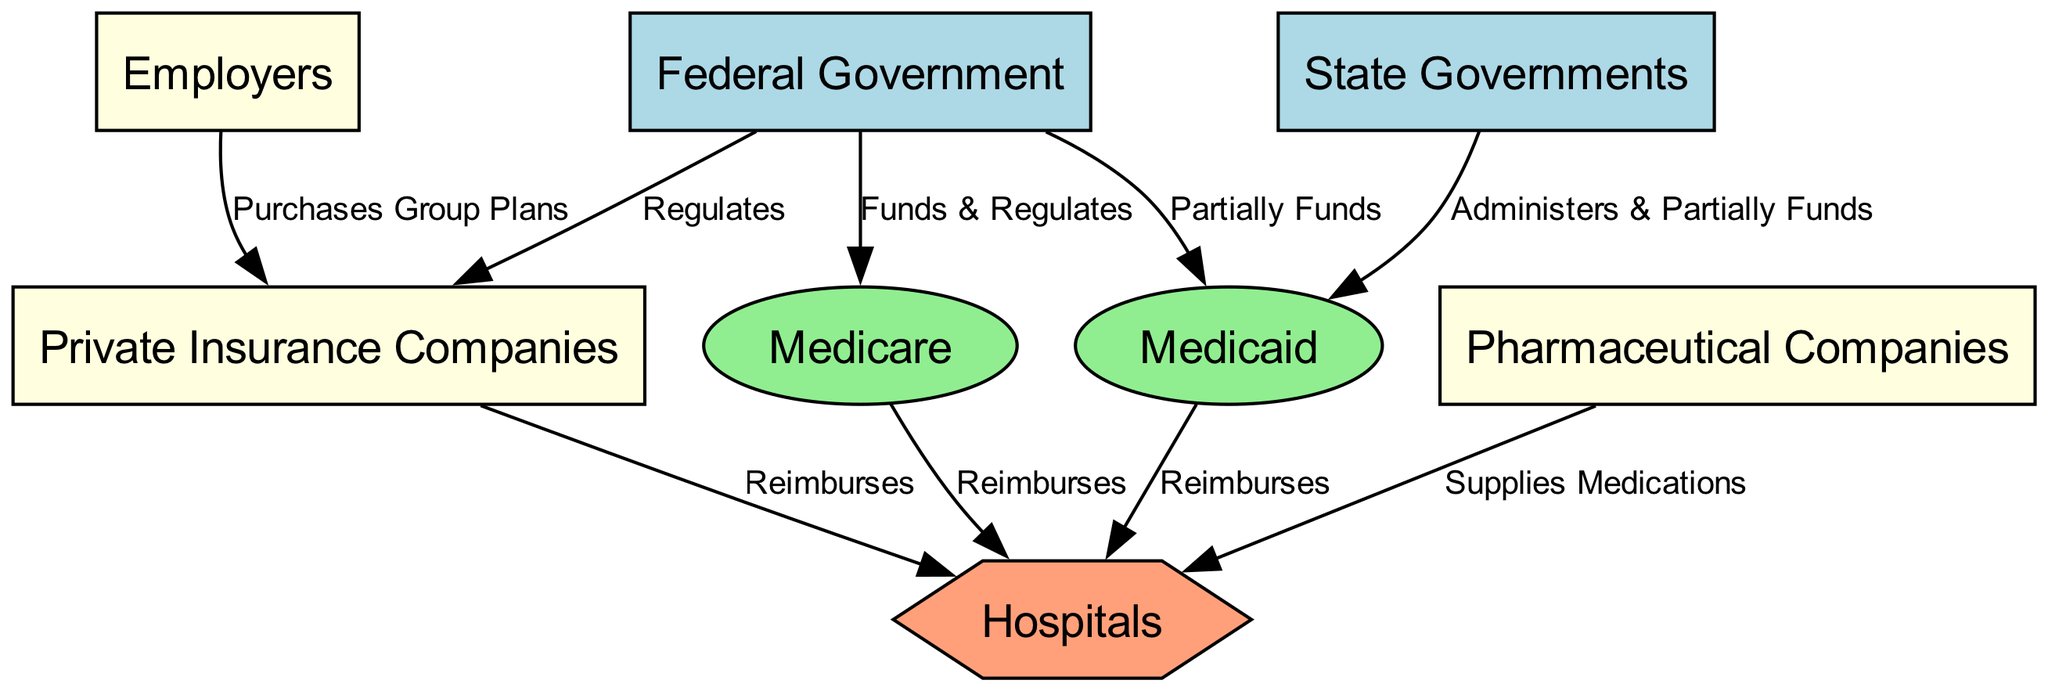What are the two major public sectors represented in the diagram? The diagram includes the Federal Government and State Governments as major public sectors. Therefore, by identifying the nodes labeled 'Federal Government' and 'State Governments', we determine that these are the specific entities in the public sector.
Answer: Federal Government, State Governments How many public health insurance entities are shown in the diagram? The diagram features two public health insurance entities: Medicare and Medicaid. These can be easily identified as the nodes labeled 'Medicare' and 'Medicaid' under the public health insurance category.
Answer: 2 Who regulates the private insurance companies? The Federal Government is responsible for regulating private insurance companies, as indicated by the edge labeled 'Regulates' that connects the Federal Government to Private Insurance Companies in the diagram.
Answer: Federal Government What action do employers take regarding private insurance companies? Employers purchase group plans from private insurance companies, which is shown through the edge labeled 'Purchases Group Plans' connecting Employers to Private Insurance Companies.
Answer: Purchases Group Plans Which sector partially funds Medicaid? State Governments partially fund Medicaid, as indicated by the edge labeled 'Administers & Partially Funds' connecting State Governments to Medicaid. This establishes the financial relationship in funding public health insurance.
Answer: State Governments Between which two types of entities does the Medicare reimbursement flow? The Medicare reimbursement flows between Medicare and Hospitals, as shown by the edge labeled 'Reimburses' connecting these two nodes. This indicates that Medicare provides financial reimbursement to hospitals for healthcare services.
Answer: Medicare, Hospitals What do pharmaceutical companies supply to hospitals? Pharmaceutical Companies supply medications to hospitals, indicated by the edge labeled 'Supplies Medications' connecting these two entities in the diagram. This highlights the role of pharmaceutical companies in the healthcare supply chain.
Answer: Medications What is the main role of the Federal Government regarding Medicare? The Federal Government funds and regulates Medicare, as indicated by the edge labeled 'Funds & Regulates' connecting these two entities in the diagram. This describes the dual responsibility of the Federal Government in managing this public health insurance program.
Answer: Funds & Regulates 